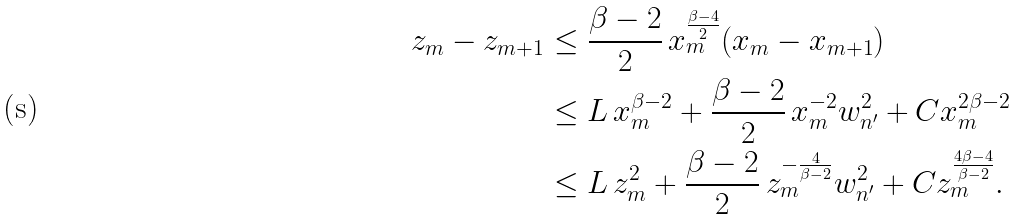Convert formula to latex. <formula><loc_0><loc_0><loc_500><loc_500>z _ { m } - z _ { m + 1 } & \leq \frac { \beta - 2 } { 2 } \, x _ { m } ^ { \frac { \beta - 4 } { 2 } } ( x _ { m } - x _ { m + 1 } ) \\ & \leq L \, x _ { m } ^ { \beta - 2 } + \frac { \beta - 2 } { 2 } \, x _ { m } ^ { - 2 } w _ { n ^ { \prime } } ^ { 2 } + C x _ { m } ^ { 2 \beta - 2 } \\ & \leq L \, z _ { m } ^ { 2 } + \frac { \beta - 2 } { 2 } \, z _ { m } ^ { - \frac { 4 } { \beta - 2 } } w _ { n ^ { \prime } } ^ { 2 } + C z _ { m } ^ { \frac { 4 \beta - 4 } { \beta - 2 } } .</formula> 